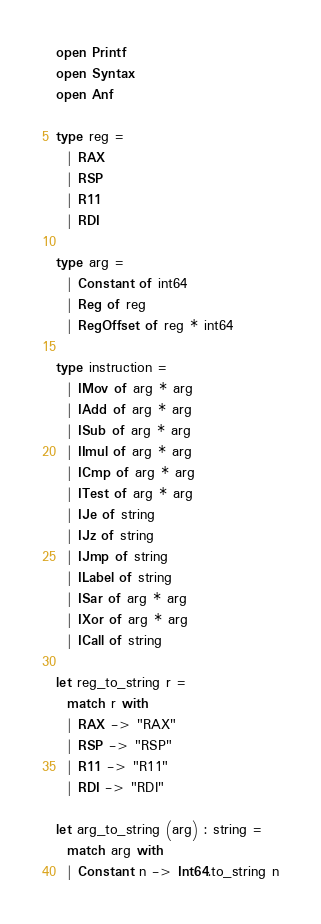Convert code to text. <code><loc_0><loc_0><loc_500><loc_500><_OCaml_>open Printf
open Syntax
open Anf

type reg = 
  | RAX
  | RSP
  | R11
  | RDI

type arg =
  | Constant of int64
  | Reg of reg
  | RegOffset of reg * int64

type instruction = 
  | IMov of arg * arg
  | IAdd of arg * arg
  | ISub of arg * arg
  | IImul of arg * arg
  | ICmp of arg * arg
  | ITest of arg * arg
  | IJe of string
  | IJz of string
  | IJmp of string
  | ILabel of string
  | ISar of arg * arg
  | IXor of arg * arg
  | ICall of string

let reg_to_string r =
  match r with
  | RAX -> "RAX"
  | RSP -> "RSP"
  | R11 -> "R11"
  | RDI -> "RDI"

let arg_to_string (arg) : string =
  match arg with
  | Constant n -> Int64.to_string n</code> 